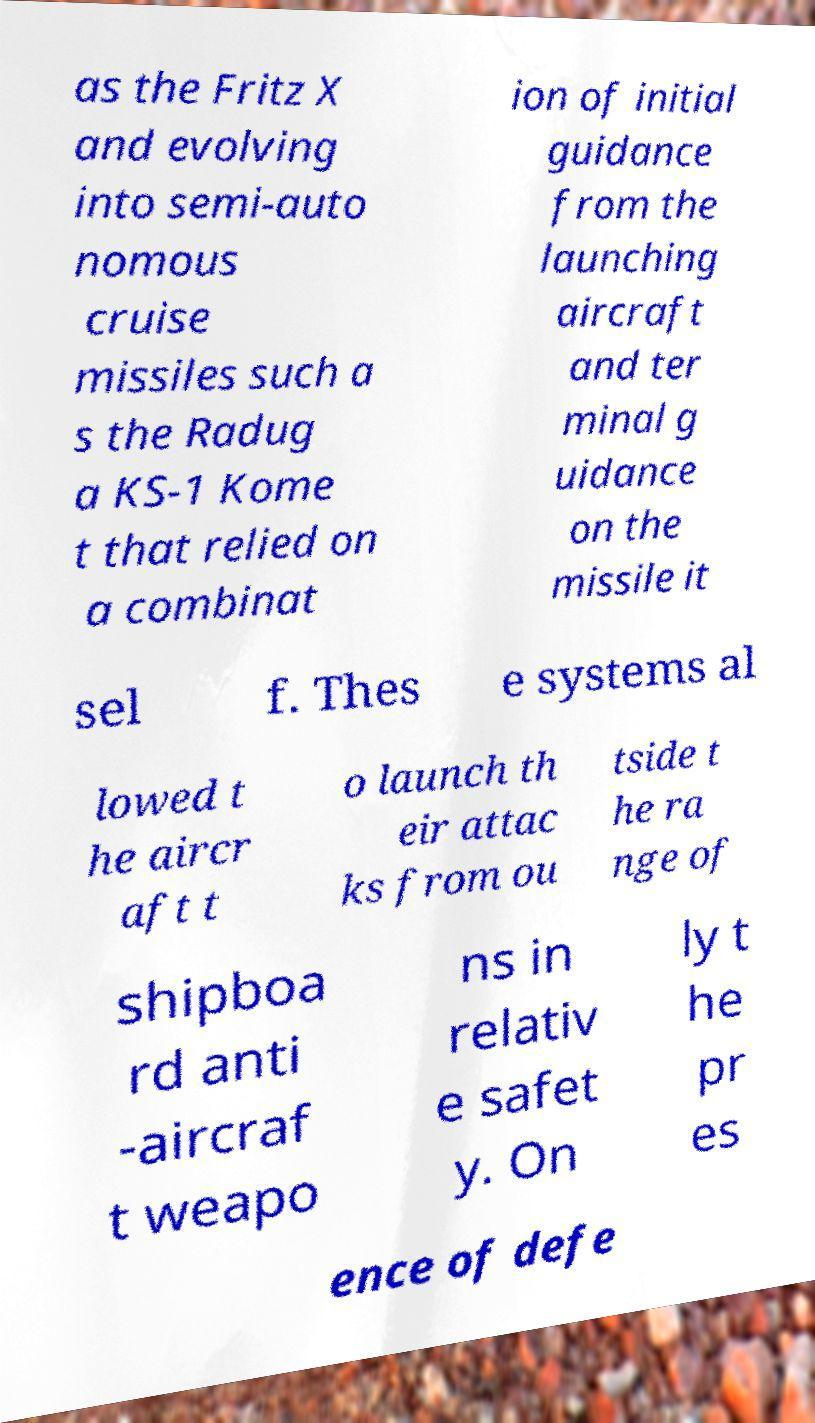Can you accurately transcribe the text from the provided image for me? as the Fritz X and evolving into semi-auto nomous cruise missiles such a s the Radug a KS-1 Kome t that relied on a combinat ion of initial guidance from the launching aircraft and ter minal g uidance on the missile it sel f. Thes e systems al lowed t he aircr aft t o launch th eir attac ks from ou tside t he ra nge of shipboa rd anti -aircraf t weapo ns in relativ e safet y. On ly t he pr es ence of defe 